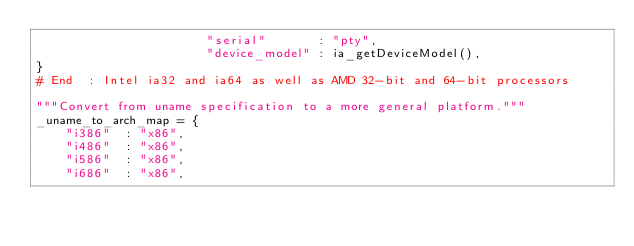<code> <loc_0><loc_0><loc_500><loc_500><_Python_>                       "serial"       : "pty",
                       "device_model" : ia_getDeviceModel(),
}
# End  : Intel ia32 and ia64 as well as AMD 32-bit and 64-bit processors

"""Convert from uname specification to a more general platform."""
_uname_to_arch_map = {
    "i386"  : "x86",
    "i486"  : "x86",
    "i586"  : "x86",
    "i686"  : "x86",</code> 